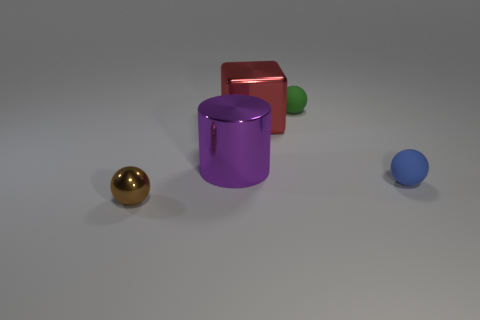Is the blue object the same shape as the small brown shiny object?
Provide a short and direct response. Yes. What number of things are both behind the small blue matte sphere and on the left side of the green ball?
Provide a succinct answer. 2. Is the number of large purple cylinders that are behind the big red thing the same as the number of purple objects right of the blue matte ball?
Offer a very short reply. Yes. There is a object that is in front of the small blue matte object; is its size the same as the metallic object that is to the right of the large purple shiny object?
Offer a very short reply. No. The thing that is in front of the purple shiny cylinder and to the left of the big red block is made of what material?
Your answer should be compact. Metal. Are there fewer blue rubber things than big yellow metal objects?
Provide a short and direct response. No. There is a object on the right side of the rubber object left of the blue object; what size is it?
Make the answer very short. Small. The tiny thing right of the small rubber ball behind the matte sphere that is in front of the purple object is what shape?
Make the answer very short. Sphere. The large object that is the same material as the big block is what color?
Ensure brevity in your answer.  Purple. There is a metallic cylinder behind the sphere that is right of the small object behind the big red shiny thing; what is its color?
Your answer should be very brief. Purple. 